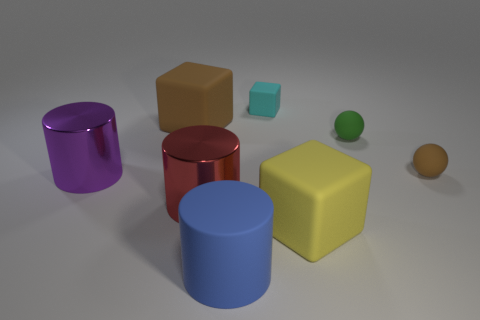Add 1 yellow matte blocks. How many objects exist? 9 Subtract all cylinders. How many objects are left? 5 Subtract all big rubber objects. Subtract all cyan matte cubes. How many objects are left? 4 Add 7 blue cylinders. How many blue cylinders are left? 8 Add 3 tiny cyan matte blocks. How many tiny cyan matte blocks exist? 4 Subtract 0 green blocks. How many objects are left? 8 